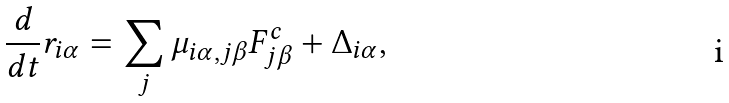Convert formula to latex. <formula><loc_0><loc_0><loc_500><loc_500>\frac { d } { d t } r _ { i \alpha } = \sum _ { j } \mu _ { i \alpha , j \beta } F _ { j \beta } ^ { c } + \Delta _ { i \alpha } ,</formula> 